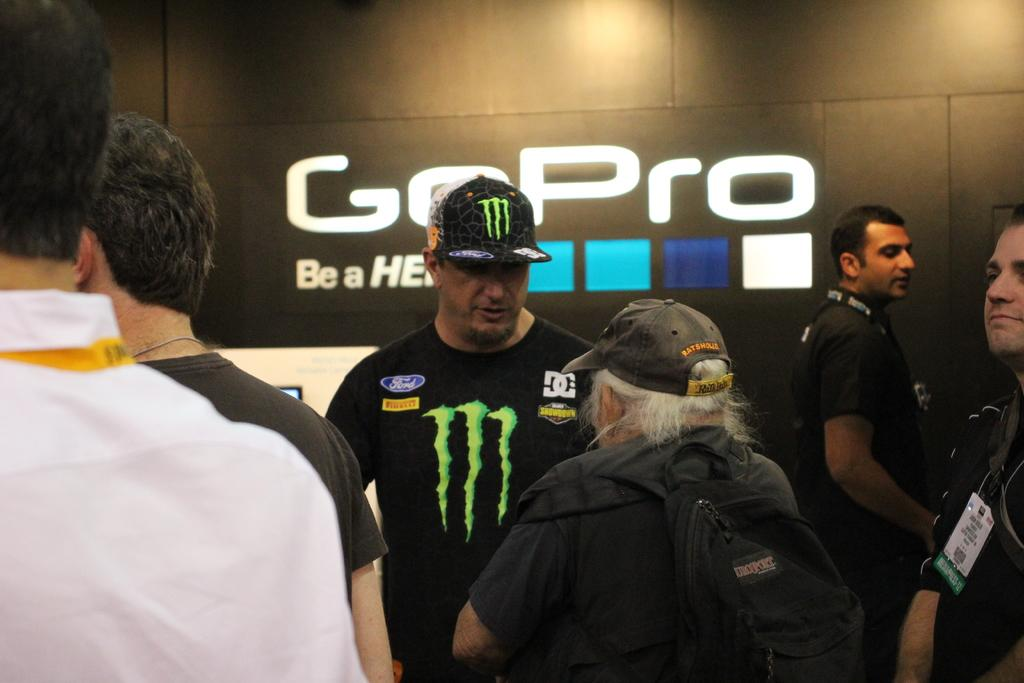Who or what is present in the image? There are people in the image. Can you describe any additional features in the background of the image? There are letters on a wall in the background of the image. What is the size of the earth as seen in the image? The earth is not visible in the image, so its size cannot be determined. 